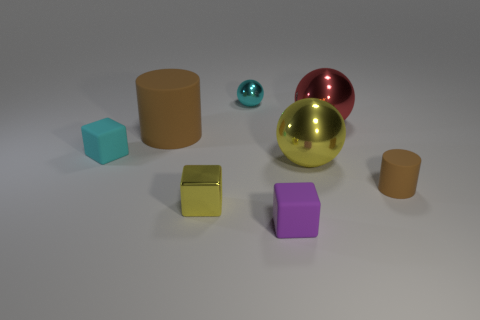Subtract all yellow cubes. How many cubes are left? 2 Add 1 small metal spheres. How many objects exist? 9 Subtract all yellow cubes. How many cubes are left? 2 Subtract 2 spheres. How many spheres are left? 1 Subtract all purple balls. Subtract all cyan blocks. How many balls are left? 3 Subtract all gray cylinders. How many purple cubes are left? 1 Subtract all big brown matte cylinders. Subtract all large yellow things. How many objects are left? 6 Add 6 small cyan matte cubes. How many small cyan matte cubes are left? 7 Add 2 big red metal balls. How many big red metal balls exist? 3 Subtract 1 red balls. How many objects are left? 7 